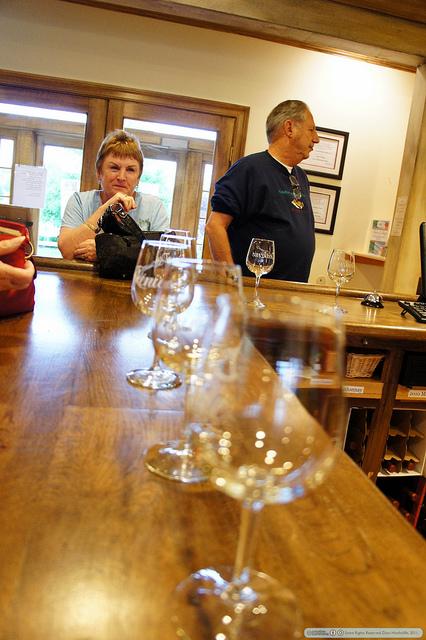What kind of glasses are on the bar?
Concise answer only. Wine. Does this scene take place at a winery?
Be succinct. Yes. Do the glasses need to be filled?
Write a very short answer. Yes. 